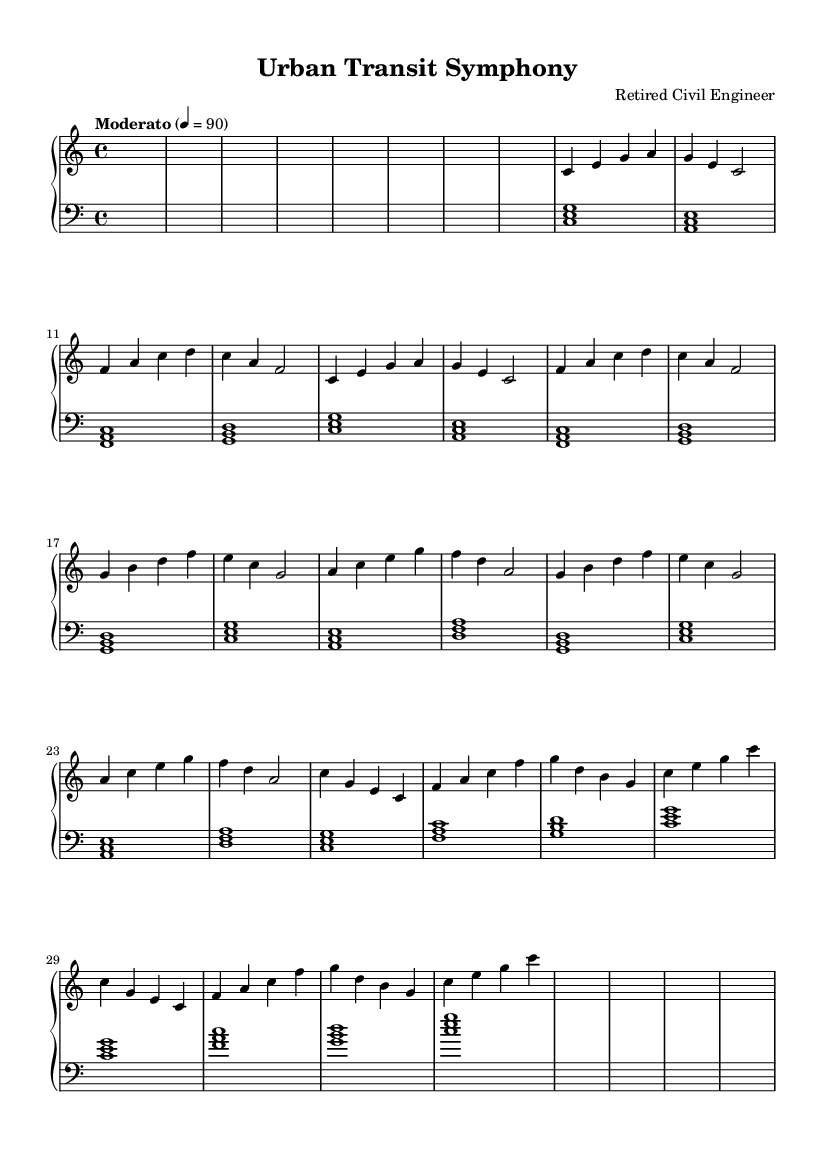What is the key signature of this music? The key signature is indicated at the beginning of the score, showing no sharps or flats. Therefore, it is in the key of C major.
Answer: C major What is the time signature of this piece? The time signature, located after the key signature at the beginning, is 4/4, which indicates four beats per measure.
Answer: 4/4 What is the tempo marking for this piece? The tempo marking appears above the staff; it indicates "Moderato" with a metronome marking of 90 beats per minute, suggesting a moderately paced performance.
Answer: Moderato, 90 How many sections are there in this composition? By analyzing the structure of the music, it is clear that there are three main sections (A, B, C) followed by a coda.
Answer: Three sections What melodic strategy is used in Section A? In Section A, a repetition of melodic phrases occurs, which adds to the cohesiveness of the section. Each phrase is repeated, which is a common technique in theme development.
Answer: Repetition What instruments are suggested by the score layout? The score layout indicates a piano staff, suggesting that one instrument, the piano, is being used to perform the piece.
Answer: Piano Which section contrasts with Section B in terms of dynamics and melodic development? Section C contrasts with Section B, as it uses a different melodic contour and developmental approach, moving from the earlier sections' simpler harmonies to more complex ones.
Answer: Section C 